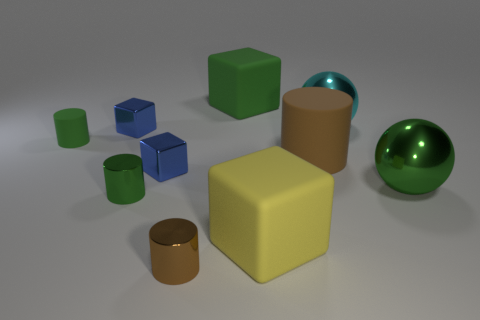Subtract 1 cylinders. How many cylinders are left? 3 Subtract all spheres. How many objects are left? 8 Subtract 1 green blocks. How many objects are left? 9 Subtract all blue cubes. Subtract all large cyan shiny spheres. How many objects are left? 7 Add 5 green balls. How many green balls are left? 6 Add 5 tiny green cylinders. How many tiny green cylinders exist? 7 